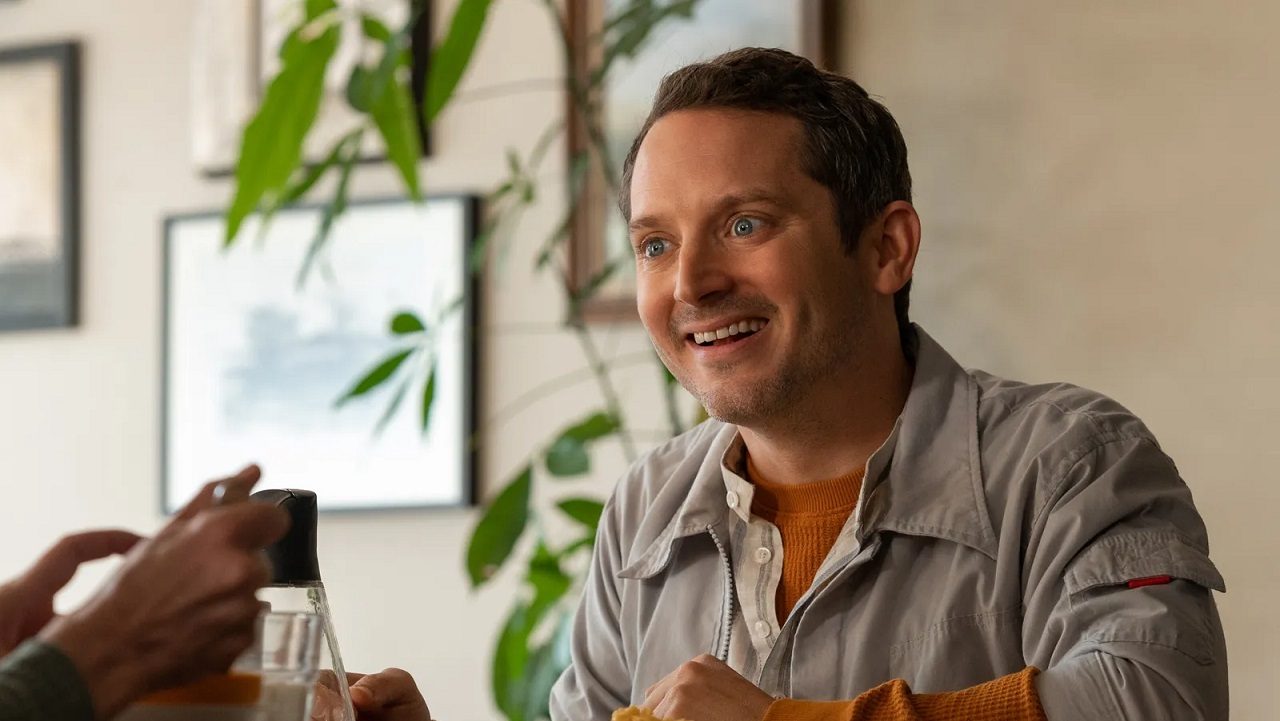What details in the clothing and background suggest anything about the personality or situation of the person? The person's clothing, namely a neat gray jacket paired with an orange sweater, suggests a stylish yet approachable personality. Such attire implies a sense of casual refinement, apt for semi-formal gatherings or casual business meetings. The background, with its serene greenery and visible urban elements, hints at an upscale urban eatery, suggesting that the person might be engaged in a casual dining experience, possibly with friends or colleagues. This combination of personal style and setting suggests a blending of personal and professional life, often characteristic of sociable and adaptable individuals. 